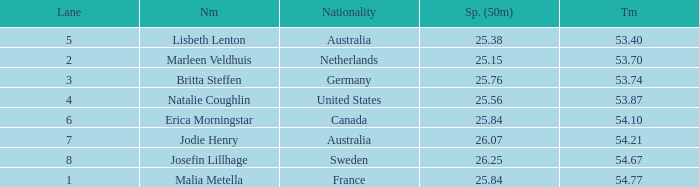What is the total sum of 50m splits for josefin lillhage in lanes above 8? None. 